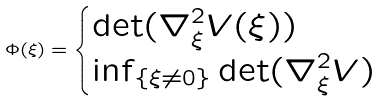<formula> <loc_0><loc_0><loc_500><loc_500>\Phi ( \xi ) = \begin{cases} \det ( \nabla _ { \xi } ^ { 2 } V ( \xi ) ) & \\ \inf _ { \{ \xi \neq 0 \} } \det ( \nabla _ { \xi } ^ { 2 } V ) & \end{cases}</formula> 